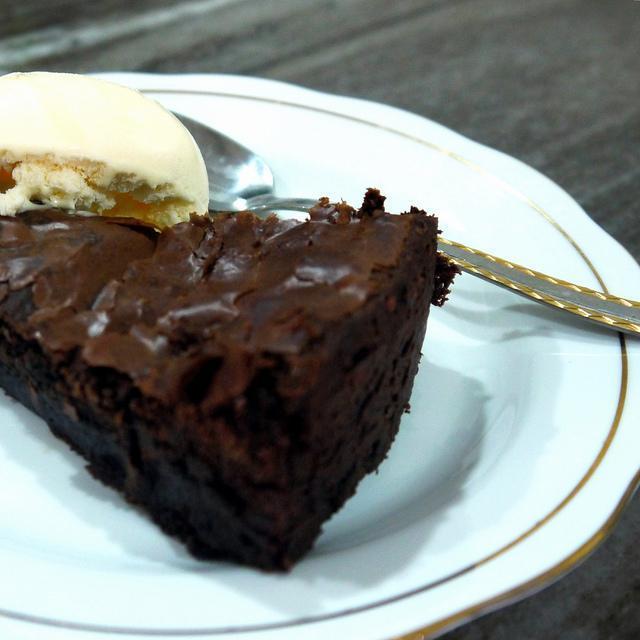How many cakes can be seen?
Give a very brief answer. 2. How many stripes of the tie are below the mans right hand?
Give a very brief answer. 0. 